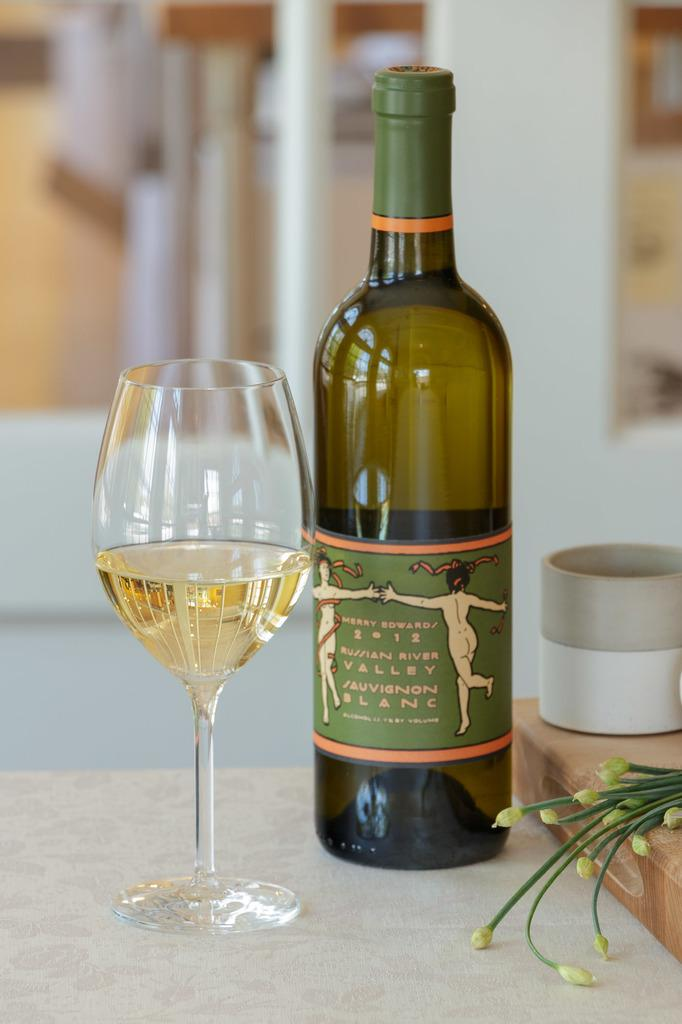<image>
Present a compact description of the photo's key features. A bottle of 2012 wine hails from the Russian River Valley. 